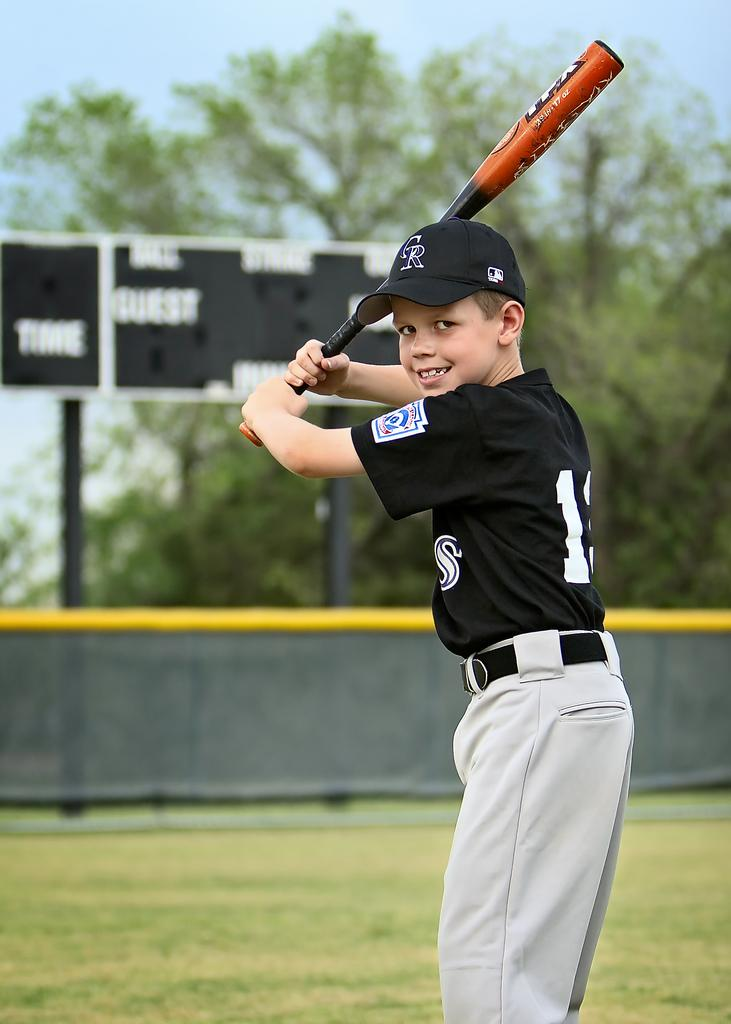<image>
Describe the image concisely. A Colorado Rockies fan is standing with a bat ready to take a swing. 